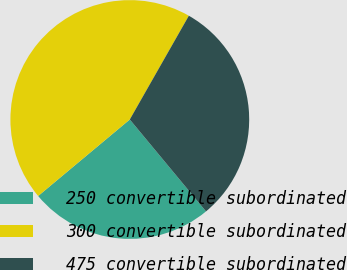Convert chart to OTSL. <chart><loc_0><loc_0><loc_500><loc_500><pie_chart><fcel>250 convertible subordinated<fcel>300 convertible subordinated<fcel>475 convertible subordinated<nl><fcel>24.95%<fcel>44.31%<fcel>30.75%<nl></chart> 